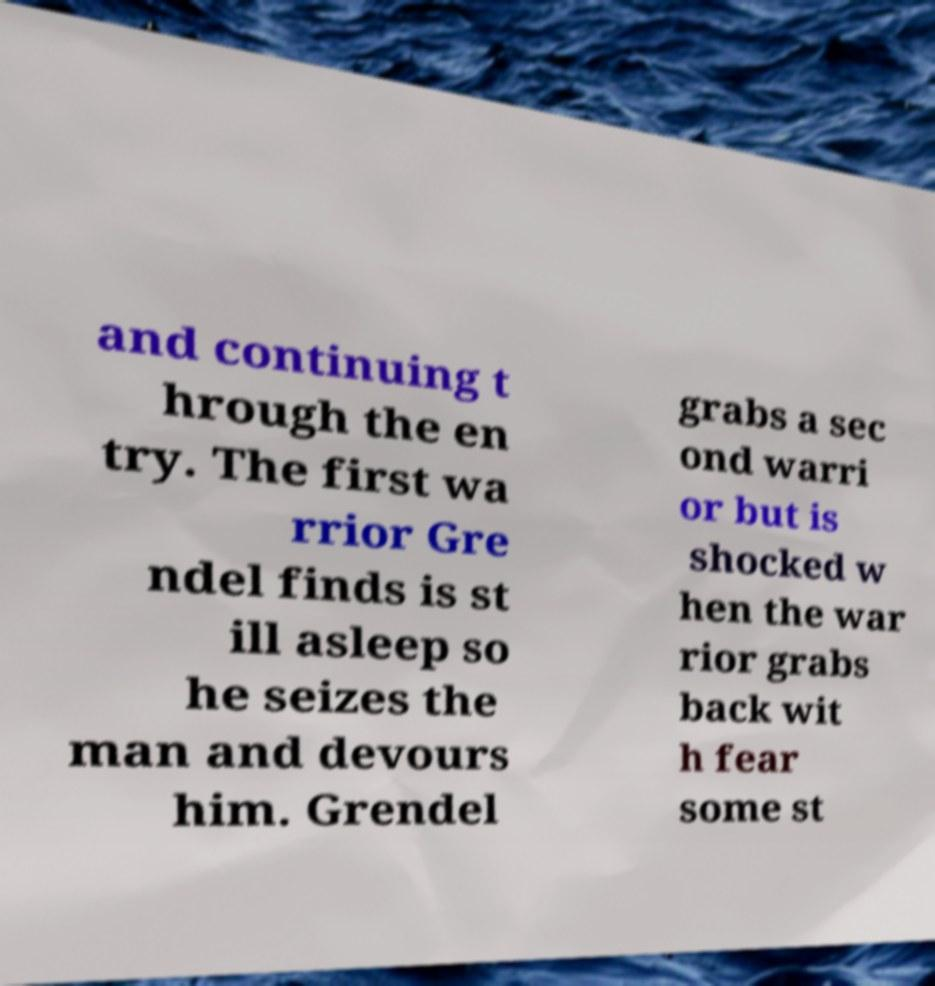Could you extract and type out the text from this image? and continuing t hrough the en try. The first wa rrior Gre ndel finds is st ill asleep so he seizes the man and devours him. Grendel grabs a sec ond warri or but is shocked w hen the war rior grabs back wit h fear some st 